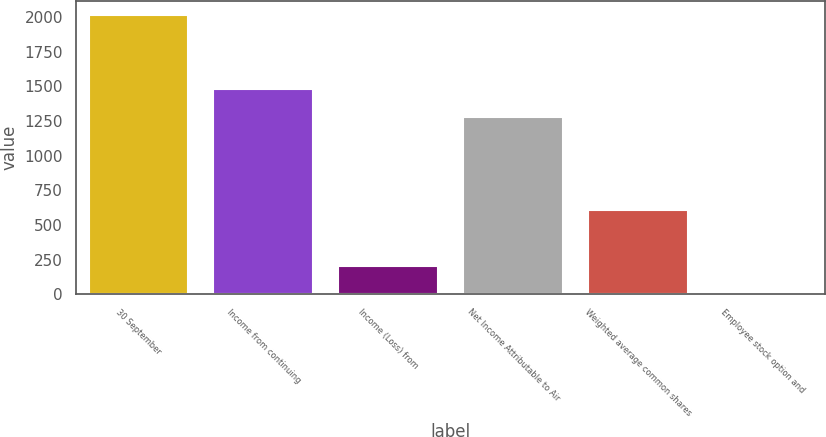<chart> <loc_0><loc_0><loc_500><loc_500><bar_chart><fcel>30 September<fcel>Income from continuing<fcel>Income (Loss) from<fcel>Net Income Attributable to Air<fcel>Weighted average common shares<fcel>Employee stock option and<nl><fcel>2015<fcel>1479.16<fcel>203.66<fcel>1277.9<fcel>606.18<fcel>2.4<nl></chart> 